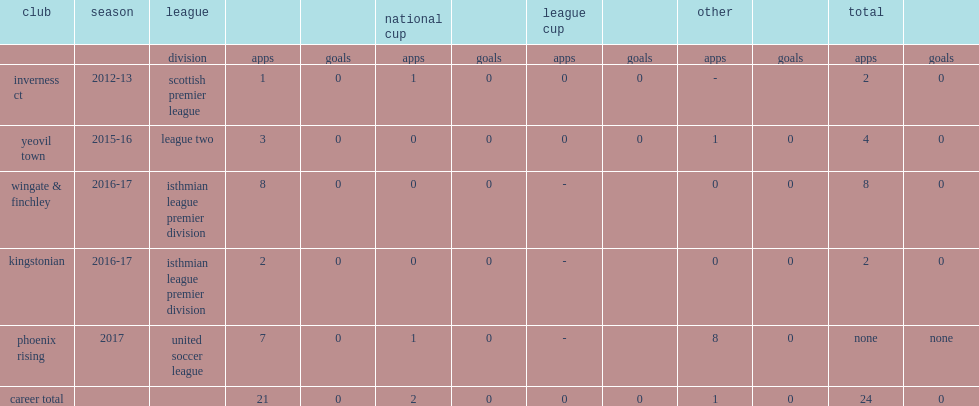Which club did gibbons play for in 2015-16? Yeovil town. 